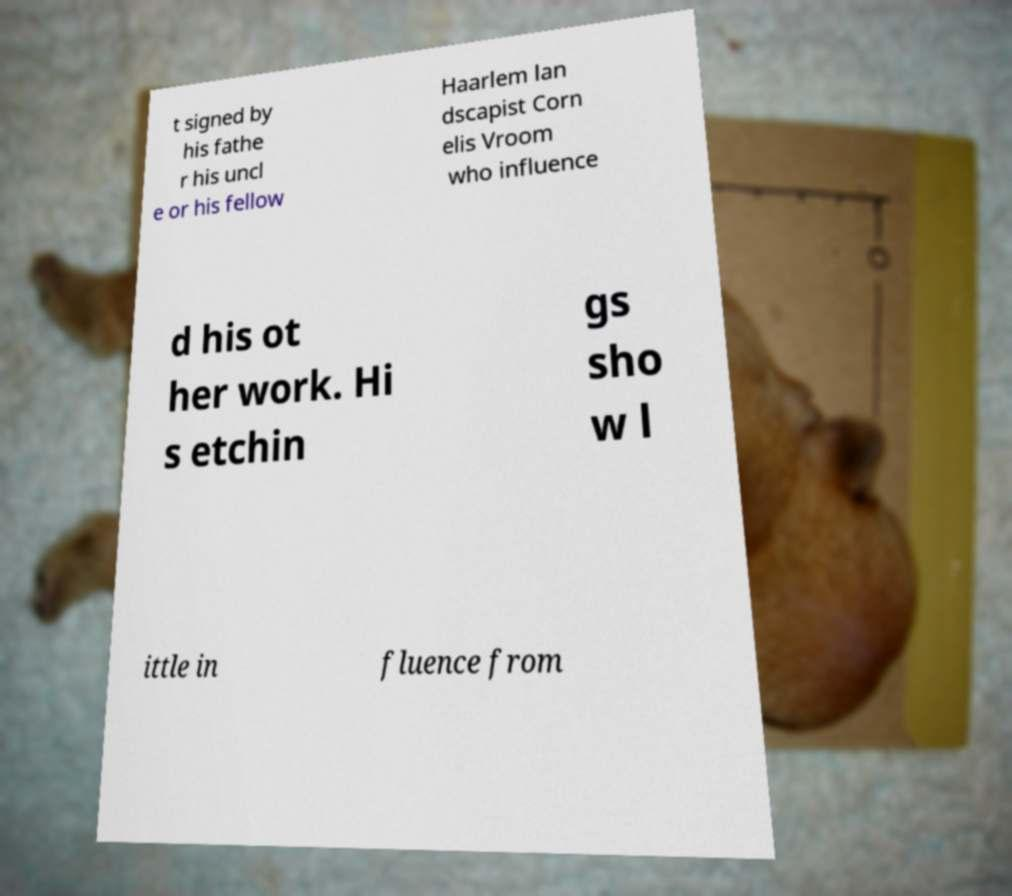There's text embedded in this image that I need extracted. Can you transcribe it verbatim? t signed by his fathe r his uncl e or his fellow Haarlem lan dscapist Corn elis Vroom who influence d his ot her work. Hi s etchin gs sho w l ittle in fluence from 